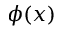Convert formula to latex. <formula><loc_0><loc_0><loc_500><loc_500>\phi ( x )</formula> 